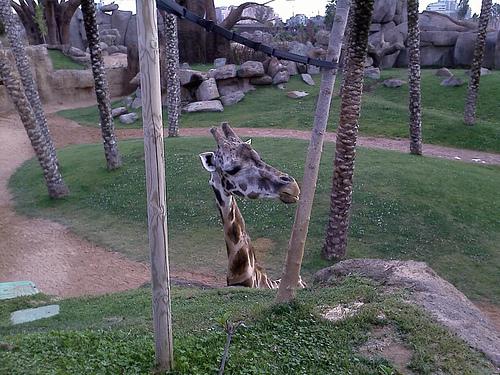What sort of trees line the pathway?
Be succinct. Palm. Is part of this animal buried?
Write a very short answer. No. Is it possible to see the animal's legs?
Write a very short answer. No. 